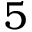Convert formula to latex. <formula><loc_0><loc_0><loc_500><loc_500>5</formula> 